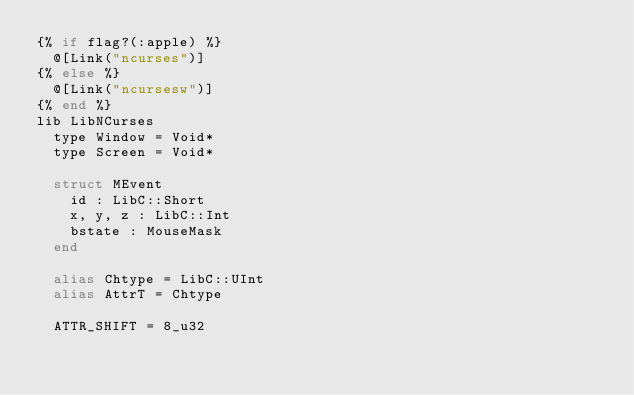Convert code to text. <code><loc_0><loc_0><loc_500><loc_500><_Crystal_>{% if flag?(:apple) %}
  @[Link("ncurses")]
{% else %}
  @[Link("ncursesw")]
{% end %}
lib LibNCurses
  type Window = Void*
  type Screen = Void*

  struct MEvent
    id : LibC::Short
    x, y, z : LibC::Int
    bstate : MouseMask
  end

  alias Chtype = LibC::UInt
  alias AttrT = Chtype

  ATTR_SHIFT = 8_u32
</code> 